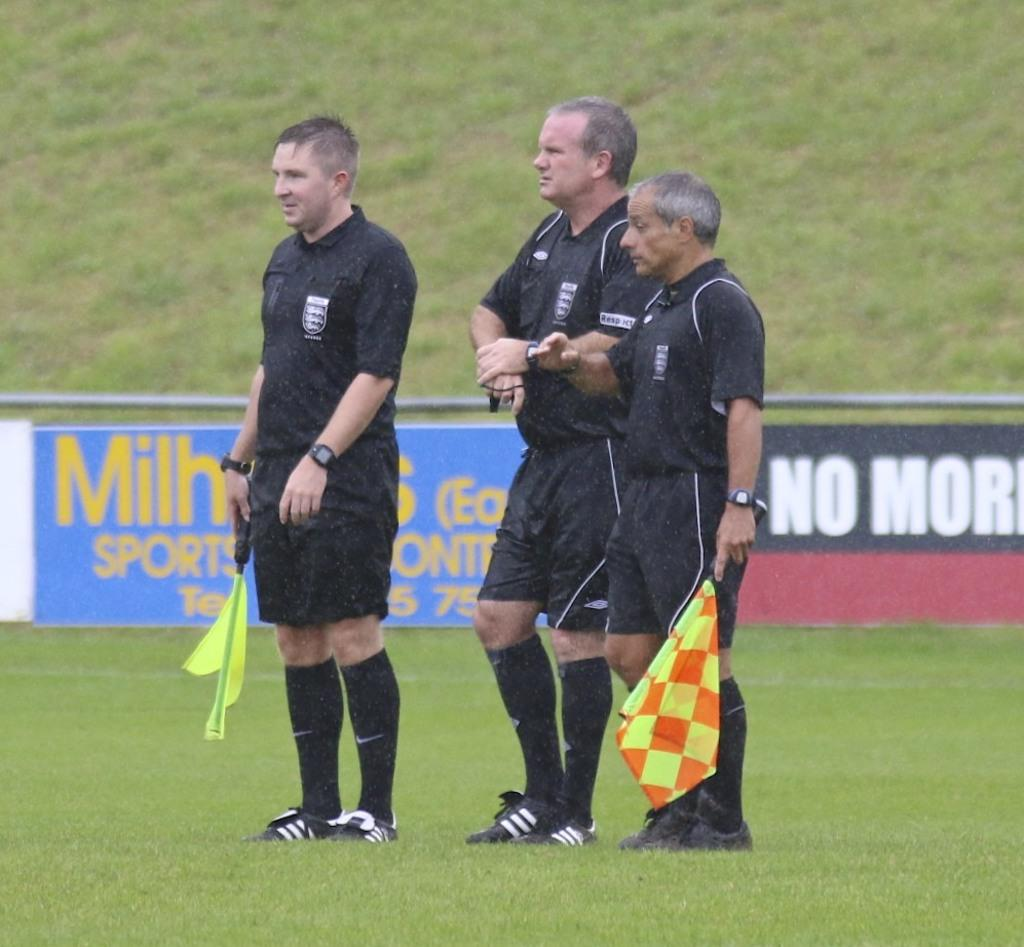How many people are in the image? There are three men in the image. What are the men wearing? The men are wearing black color dress. What are the men holding in the image? The men are holding flags. What type of surface can be seen in the image? There is grass visible in the image. What else can be seen in the image besides the men and grass? There are banners in the image. What type of silver dress is the man wearing in the image? There is no silver dress present in the image; the men are wearing black color dress. Can you see any ants crawling on the grass in the image? There is no indication of ants in the image; it only shows three men holding flags, grass, and banners. 